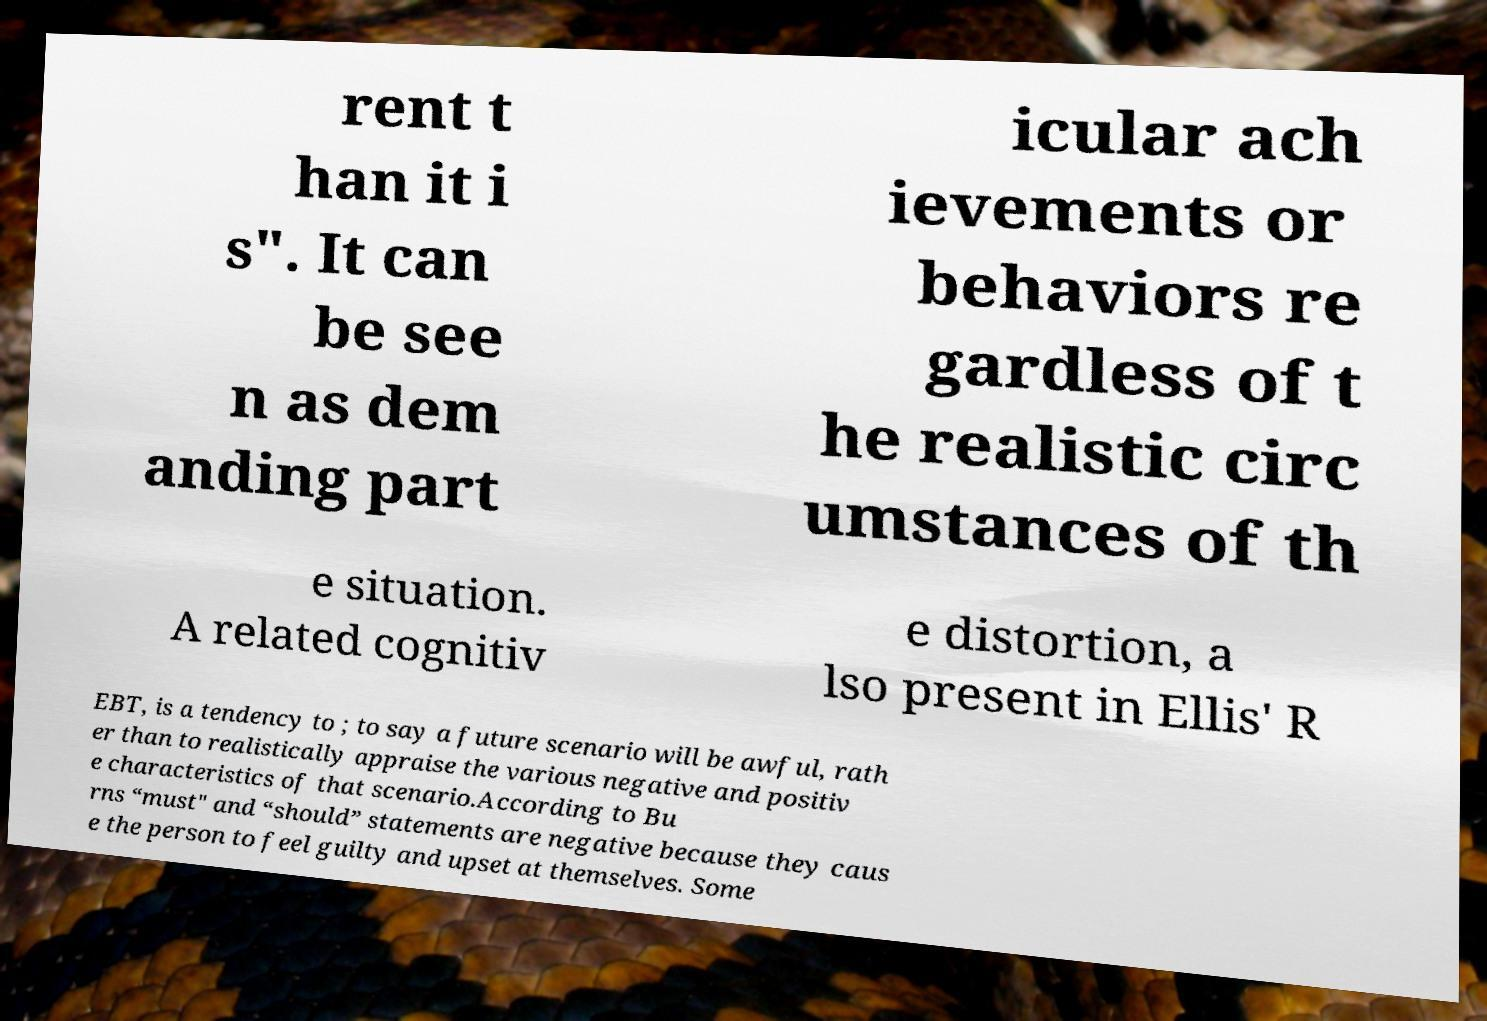For documentation purposes, I need the text within this image transcribed. Could you provide that? rent t han it i s". It can be see n as dem anding part icular ach ievements or behaviors re gardless of t he realistic circ umstances of th e situation. A related cognitiv e distortion, a lso present in Ellis' R EBT, is a tendency to ; to say a future scenario will be awful, rath er than to realistically appraise the various negative and positiv e characteristics of that scenario.According to Bu rns “must" and “should” statements are negative because they caus e the person to feel guilty and upset at themselves. Some 